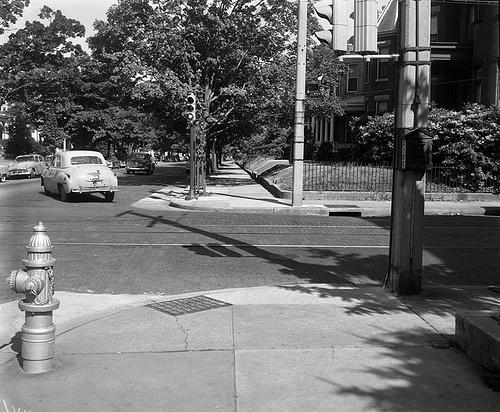What year is this picture?
Write a very short answer. 1950. What traffic light is on?
Write a very short answer. Green. Was the picture taken on a street corner?
Be succinct. Yes. 